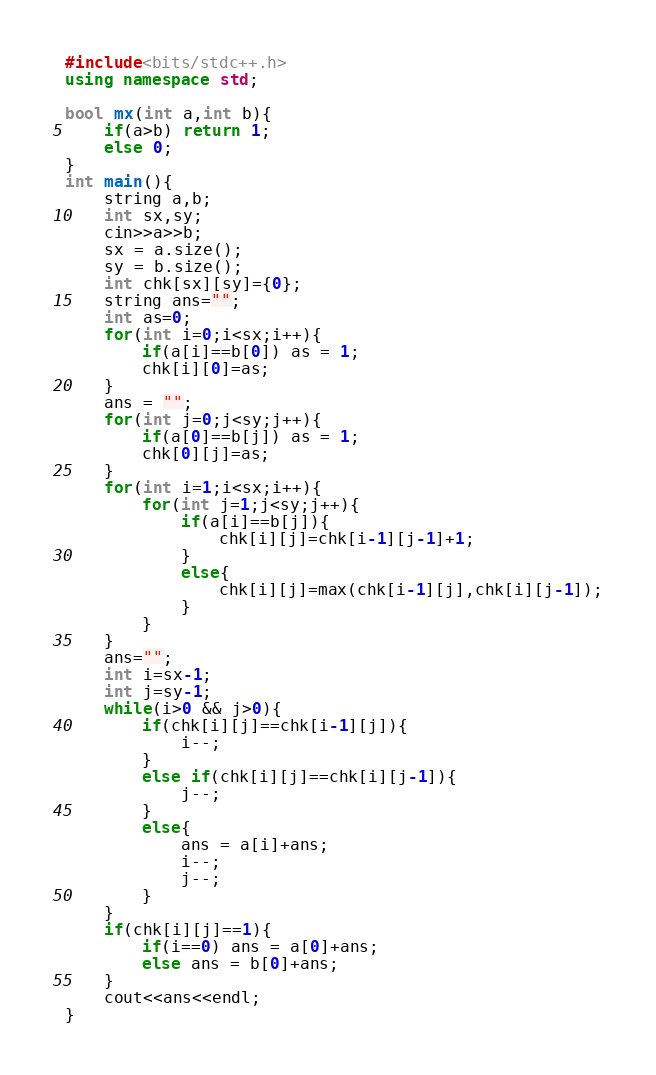<code> <loc_0><loc_0><loc_500><loc_500><_C++_>#include<bits/stdc++.h>
using namespace std;

bool mx(int a,int b){
    if(a>b) return 1;
    else 0;
}
int main(){
    string a,b;
    int sx,sy;
    cin>>a>>b;
    sx = a.size();
    sy = b.size();
    int chk[sx][sy]={0};
    string ans="";
    int as=0;
    for(int i=0;i<sx;i++){
        if(a[i]==b[0]) as = 1;
        chk[i][0]=as;
    }
    ans = "";
    for(int j=0;j<sy;j++){
        if(a[0]==b[j]) as = 1;
        chk[0][j]=as;
    }
    for(int i=1;i<sx;i++){
        for(int j=1;j<sy;j++){
            if(a[i]==b[j]){ 
                chk[i][j]=chk[i-1][j-1]+1;
            }
            else{
                chk[i][j]=max(chk[i-1][j],chk[i][j-1]);
            }
        }
    }
    ans="";
    int i=sx-1;
    int j=sy-1;
    while(i>0 && j>0){
        if(chk[i][j]==chk[i-1][j]){
            i--;
        }
        else if(chk[i][j]==chk[i][j-1]){
            j--;
        }
        else{
            ans = a[i]+ans;
            i--;
            j--;
        }
    }
    if(chk[i][j]==1){
        if(i==0) ans = a[0]+ans;
        else ans = b[0]+ans;
    }
    cout<<ans<<endl;
}</code> 